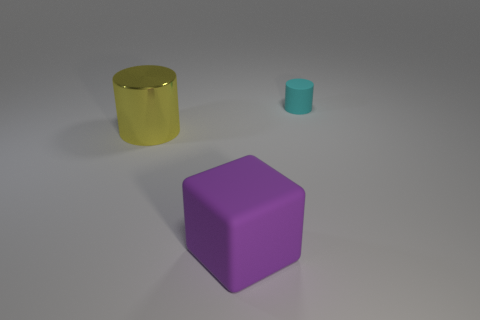There is a thing that is in front of the cyan thing and behind the big cube; what material is it?
Provide a short and direct response. Metal. There is a large object on the right side of the cylinder that is in front of the cyan thing on the right side of the big matte thing; what is its color?
Your answer should be compact. Purple. What color is the block that is the same size as the yellow cylinder?
Your response must be concise. Purple. Is the color of the tiny thing the same as the cylinder in front of the tiny cyan thing?
Provide a short and direct response. No. The cylinder in front of the cylinder on the right side of the large purple object is made of what material?
Offer a very short reply. Metal. How many things are both on the right side of the metal object and behind the cube?
Offer a terse response. 1. What number of other objects are the same size as the yellow metal cylinder?
Your answer should be compact. 1. Do the yellow object behind the purple rubber block and the matte thing behind the big purple thing have the same shape?
Your answer should be compact. Yes. Are there any cylinders on the left side of the tiny cyan cylinder?
Provide a short and direct response. Yes. What color is the metal thing that is the same shape as the tiny matte object?
Provide a succinct answer. Yellow. 